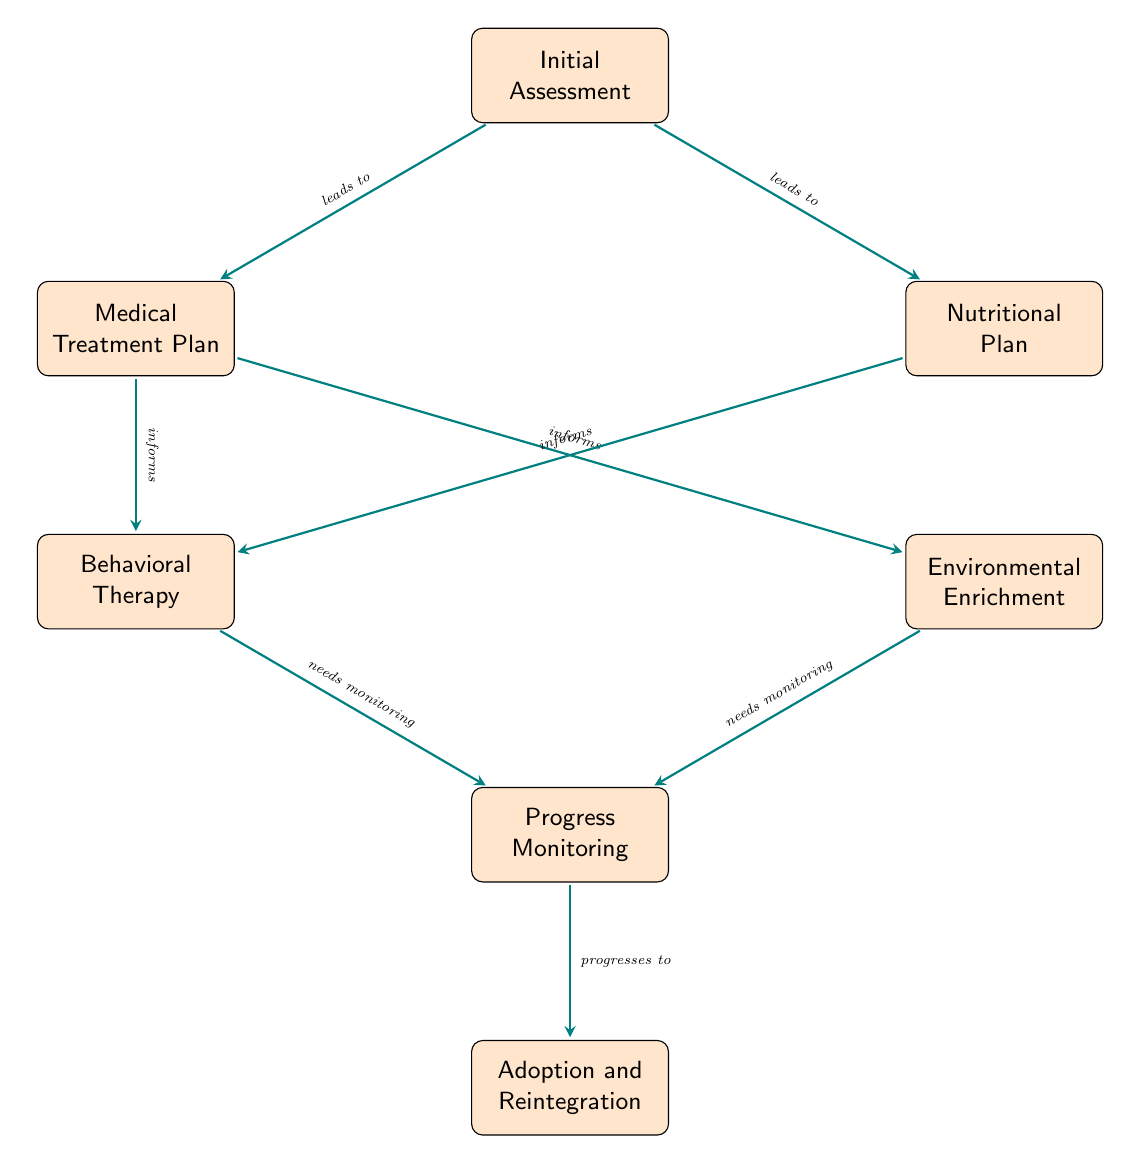What is the first step in the rehabilitation plan? The diagram indicates that the first step is "Initial Assessment", which evaluates the animal's physical and psychological conditions.
Answer: Initial Assessment How many nodes are present in the diagram? The diagram displays a total of seven nodes, representing different steps in the rehabilitation and recovery plan.
Answer: 7 What type of therapy follows the medical treatment plan? According to the connections in the diagram, "Behavioral Therapy" follows the "Medical Treatment Plan" as it is informed by it.
Answer: Behavioral Therapy Which two nodes lead to the progress monitoring stage? The nodes "Behavioral Therapy" and "Environmental Enrichment" need monitoring and both connect to "Progress Monitoring".
Answer: Behavioral Therapy, Environmental Enrichment What is the final outcome of the rehabilitation process? The last node connected to the flow is "Adoption and Reintegration," indicating that the rehabilitation process ends with preparing the animal for adoption or reintroduction.
Answer: Adoption and Reintegration Which node is the starting point for the nutritional and medical treatment plans? The "Initial Assessment" node leads directly to both "Medical Treatment Plan" and "Nutritional Plan", marking it as the starting point.
Answer: Initial Assessment How many arrows indicate the need for monitoring? There are two arrows labeled "needs monitoring" leading from "Behavioral Therapy" and "Environmental Enrichment" to "Progress Monitoring".
Answer: 2 What do the arrows from the medical treatment plan inform about? The arrows from the "Medical Treatment Plan" inform both "Behavioral Therapy" and "Environmental Enrichment", indicating that they are influenced by the medical plan.
Answer: Behavioral Therapy, Environmental Enrichment 